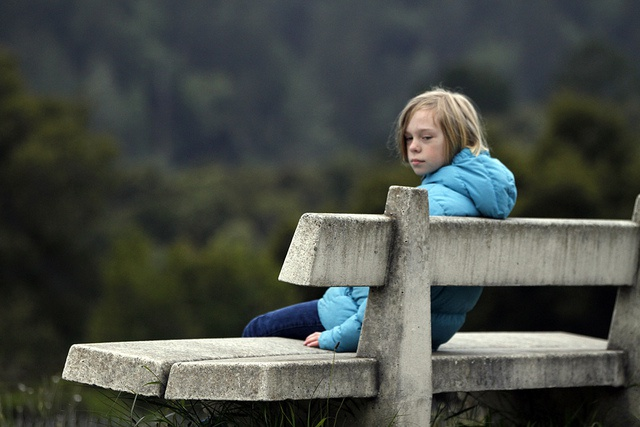Describe the objects in this image and their specific colors. I can see bench in black, darkgray, gray, and beige tones and people in black, lightblue, and gray tones in this image. 